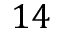Convert formula to latex. <formula><loc_0><loc_0><loc_500><loc_500>1 4</formula> 